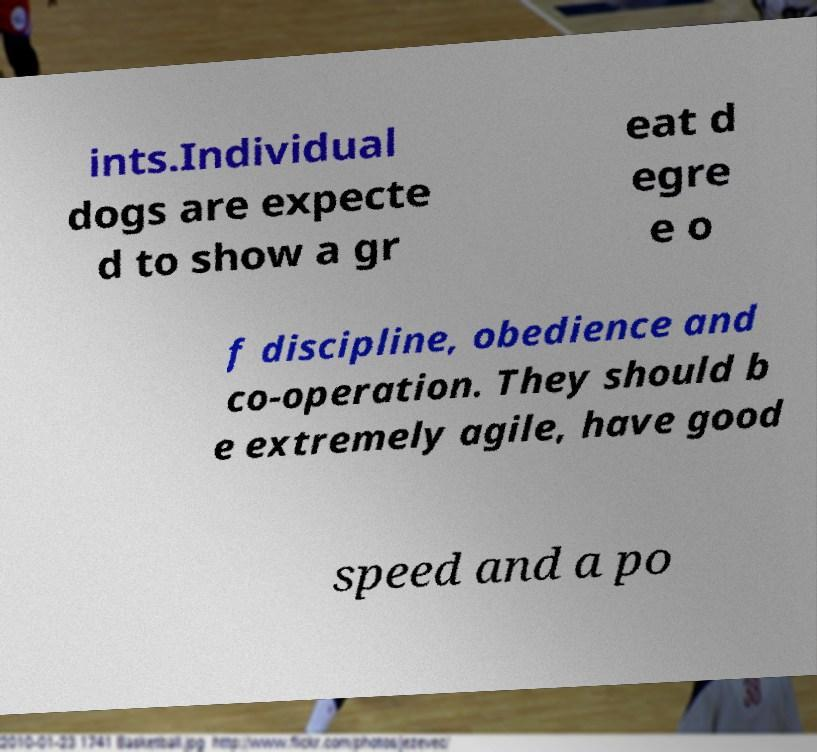Can you read and provide the text displayed in the image?This photo seems to have some interesting text. Can you extract and type it out for me? ints.Individual dogs are expecte d to show a gr eat d egre e o f discipline, obedience and co-operation. They should b e extremely agile, have good speed and a po 